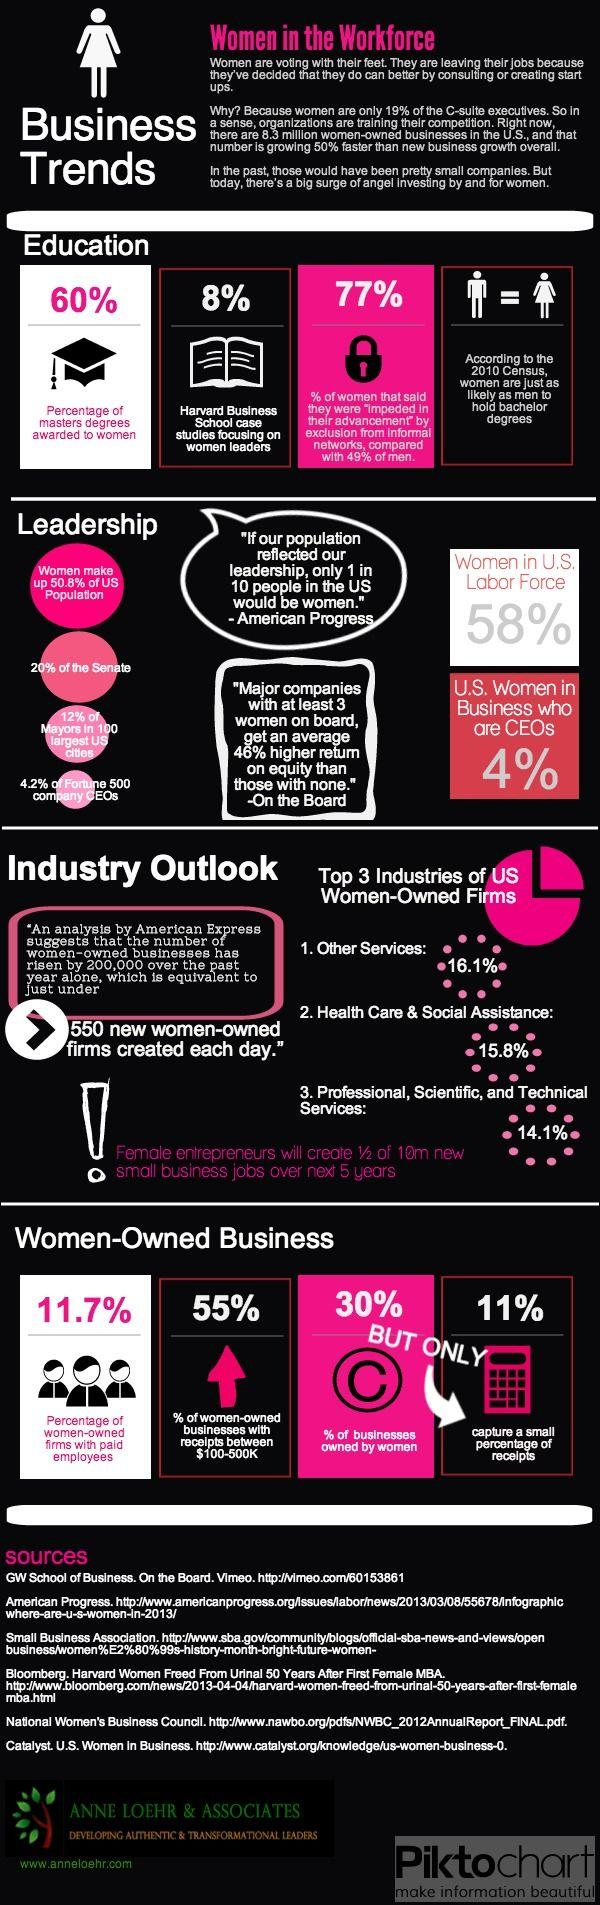Mention a couple of crucial points in this snapshot. The number of sources listed at the bottom is six. Approximately 40% of master's degrees are awarded to men. 